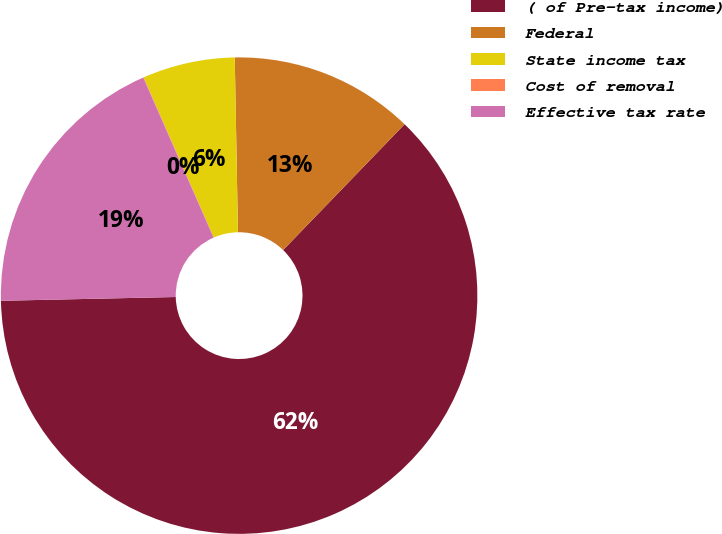Convert chart. <chart><loc_0><loc_0><loc_500><loc_500><pie_chart><fcel>( of Pre-tax income)<fcel>Federal<fcel>State income tax<fcel>Cost of removal<fcel>Effective tax rate<nl><fcel>62.43%<fcel>12.51%<fcel>6.27%<fcel>0.03%<fcel>18.75%<nl></chart> 